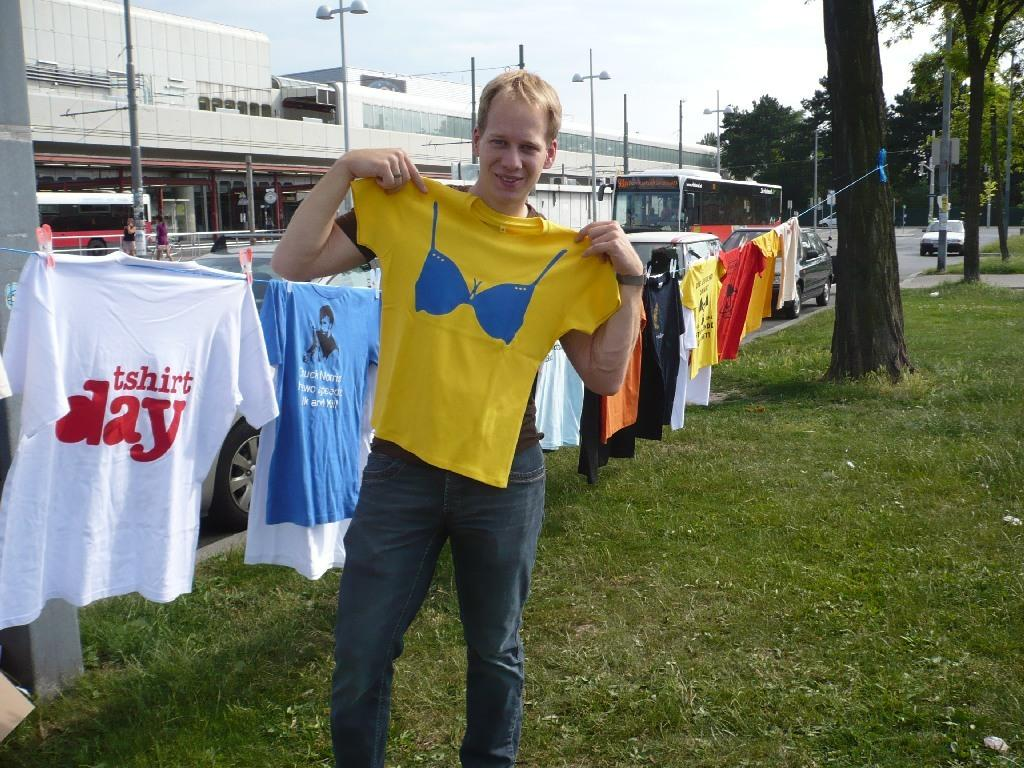<image>
Share a concise interpretation of the image provided. A young man holding up a yellow T-Shirt with a bra on the front while other T-shirts are displayed on a line behind him for T-shirt Day. 